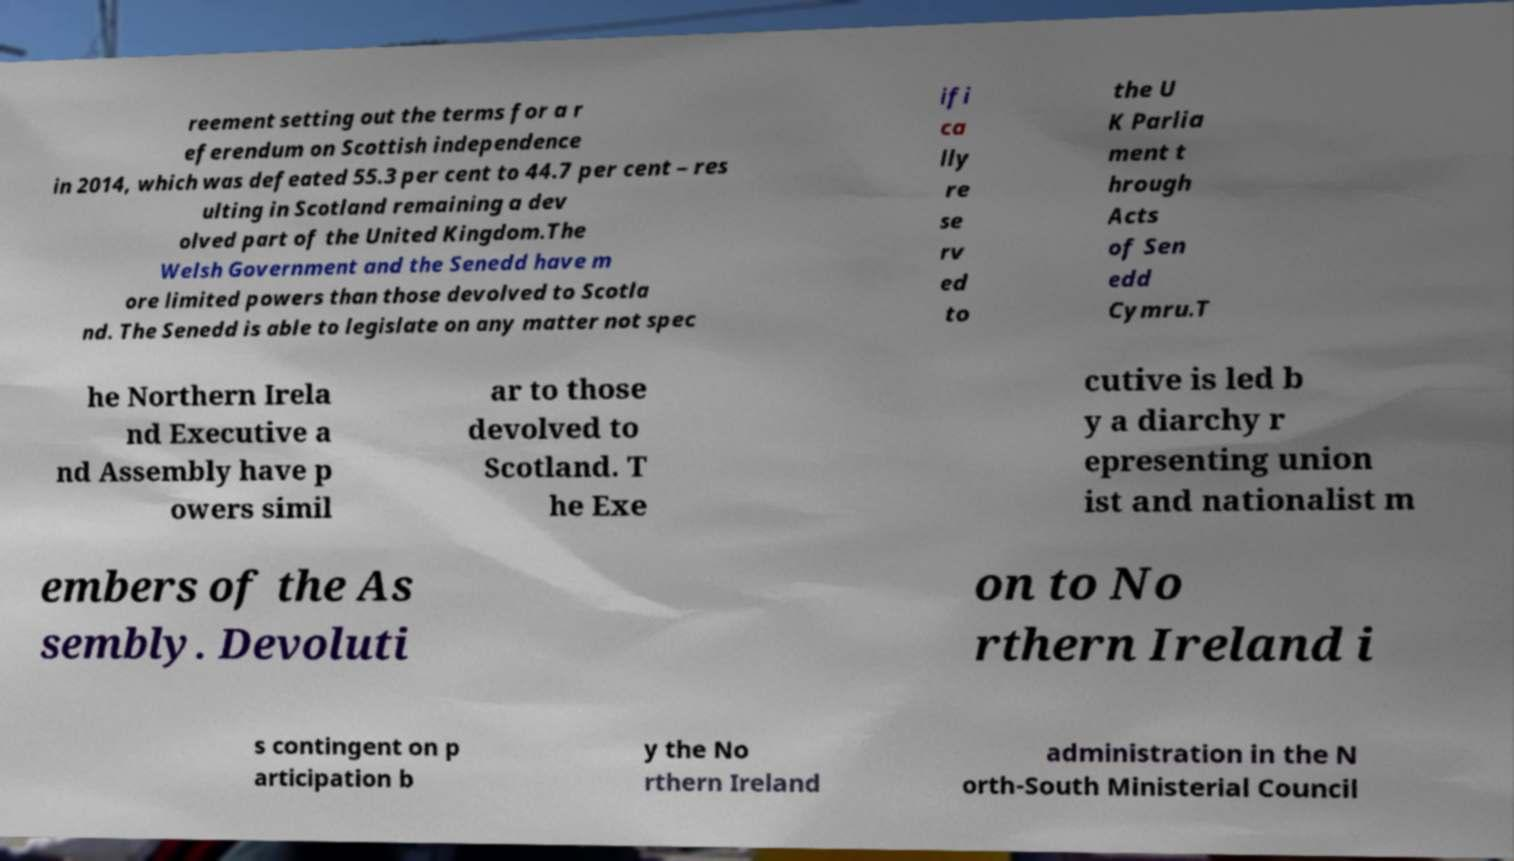Can you accurately transcribe the text from the provided image for me? reement setting out the terms for a r eferendum on Scottish independence in 2014, which was defeated 55.3 per cent to 44.7 per cent – res ulting in Scotland remaining a dev olved part of the United Kingdom.The Welsh Government and the Senedd have m ore limited powers than those devolved to Scotla nd. The Senedd is able to legislate on any matter not spec ifi ca lly re se rv ed to the U K Parlia ment t hrough Acts of Sen edd Cymru.T he Northern Irela nd Executive a nd Assembly have p owers simil ar to those devolved to Scotland. T he Exe cutive is led b y a diarchy r epresenting union ist and nationalist m embers of the As sembly. Devoluti on to No rthern Ireland i s contingent on p articipation b y the No rthern Ireland administration in the N orth-South Ministerial Council 